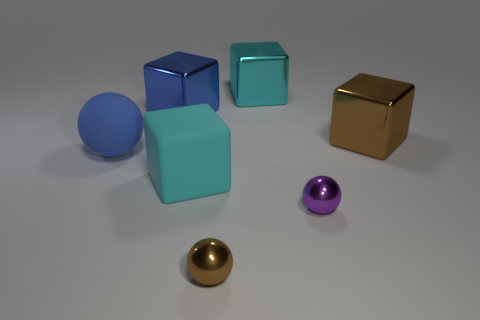What materials do the objects in the image seem to be made of? The objects in the image appear to have various materials: the large cubes seem to have matte and metallic finishes, the balls present rubbery and shiny metallic textures, and the overall arrangement suggests a variety of material properties. 